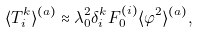Convert formula to latex. <formula><loc_0><loc_0><loc_500><loc_500>\langle T _ { i } ^ { k } \rangle ^ { ( a ) } \approx \lambda _ { 0 } ^ { 2 } \delta _ { i } ^ { k } F _ { 0 } ^ { ( i ) } \langle \varphi ^ { 2 } \rangle ^ { ( a ) } ,</formula> 